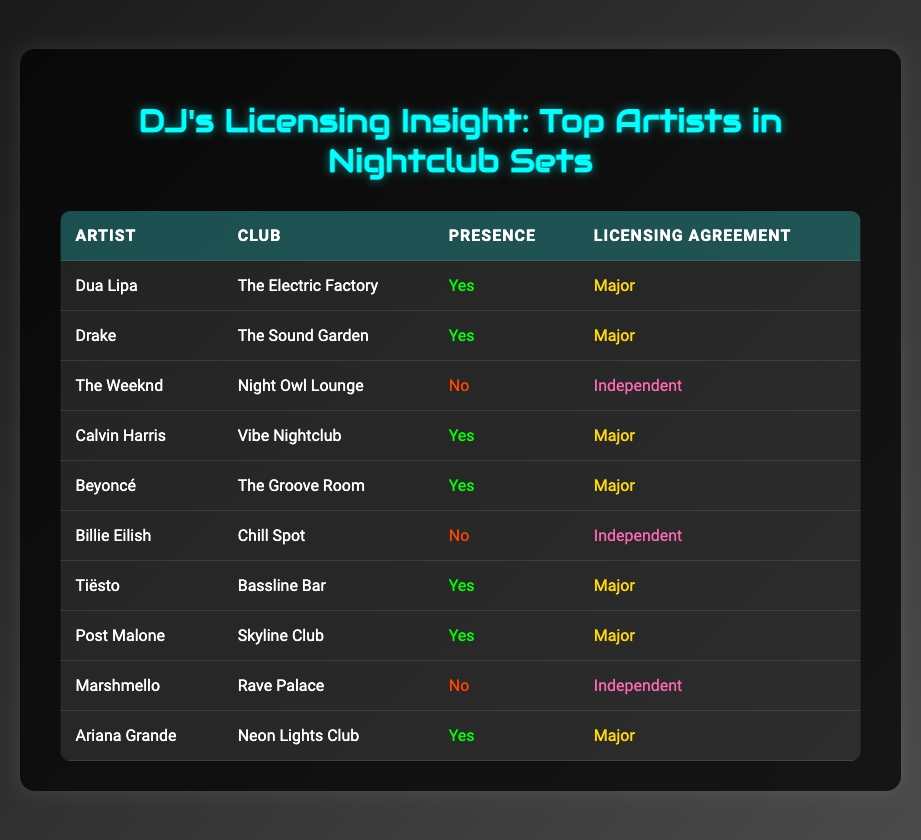What is the presence of Billie Eilish in nightclub sets? Billie Eilish's presence in nightclub sets can be found in the table under the "Presence" column. It shows "No" for her row, indicating she isn't present in any sets.
Answer: No How many artists have a major licensing agreement and are present in nightclub sets? By checking the rows with "Yes" under the "Presence" column, we see that the artists with a major licensing agreement are Dua Lipa, Drake, Calvin Harris, Beyoncé, Tiësto, Post Malone, and Ariana Grande. There are a total of 7 artists fitting this criteria.
Answer: 7 Is The Weeknd present in any nightclub sets? The Weeknd's row indicates "No" under the "Presence" column, meaning he is not present in any nightclub sets.
Answer: No How many artists in the table have an independent licensing agreement? Counting the rows with "Independent" under the Licensing Agreement column gives us Billie Eilish, The Weeknd, and Marshmello. This totals to 3 artists with an independent licensing agreement.
Answer: 3 Which artist is the only one from the club 'Rave Palace'? From the table, scanning the "Club" column reveals that only Marshmello is associated with the 'Rave Palace'.
Answer: Marshmello What is the total number of artists presented in the table? The table lists 10 distinct artists represented in the rows. Counting each unique artist will bring us to the total of 10.
Answer: 10 Are there any independent artists that have a presence in nightclub sets? Looking through the "Presence" column for rows with "Yes" and checking their corresponding "Licensing Agreement" indicates that artists with an independent agreement do not have a presence. Both Billie Eilish and Marshmello are absent from nightclub sets.
Answer: No How many clubs have artists present with major licensing agreements? The artists with a presence (Yes) and a major licensing agreement are at The Electric Factory, The Sound Garden, Vibe Nightclub, The Groove Room, Bassline Bar, Skyline Club, and Neon Lights Club. This totals to 7 different clubs.
Answer: 7 What percentage of artists listed have a presence in nightclub sets? We have a total of 10 artists and 7 of them are marked with "Yes" for presence, so the percentage is (7/10) * 100 = 70%.
Answer: 70% 